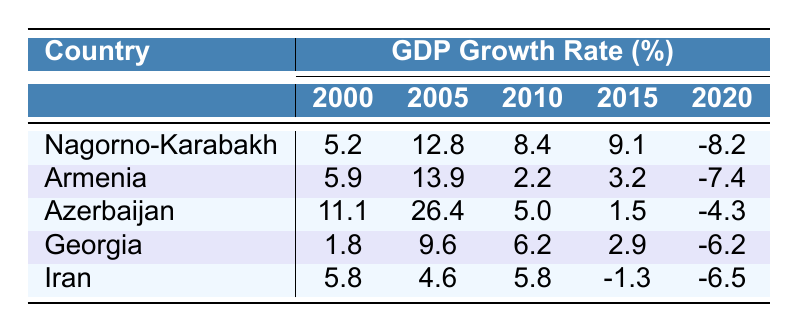What was the GDP growth rate of Nagorno-Karabakh in 2015? According to the table, the value in the row for Nagorno-Karabakh under the year 2015 is 9.1.
Answer: 9.1 Which country had the highest GDP growth rate in 2010? By looking at the table, the highest value in the row for 2010 is 11.1, which corresponds to Azerbaijan.
Answer: Azerbaijan What is the average GDP growth rate of Armenia from 2000 to 2020? To calculate the average, first sum the GDP growth rates for Armenia: (5.9 + 13.9 + 2.2 + 3.2 - 7.4) = 17.8. Then, divide by the number of years, which is 5: 17.8/5 = 3.56.
Answer: 3.56 Did Nagorno-Karabakh experience negative GDP growth in 2020? In the table, Nagorno-Karabakh has a value of -8.2 for the year 2020, which indicates negative growth.
Answer: Yes Which country showed the smallest GDP growth rate in 2005? Looking at the row for 2005, the smallest GDP growth rate is found under Georgia with a value of 9.6.
Answer: Georgia What was the change in GDP growth rate of Azerbaijan from 2015 to 2020? The GDP growth rate for Azerbaijan decreased from 1.5 in 2015 to -4.3 in 2020. To find the change, subtract the two values: 1.5 - (-4.3) = 1.5 + 4.3 = 5.8, indicating a drop.
Answer: 5.8 drop Which nations had positive GDP growth rates in 2000? By checking the values for 2000, both Azerbaijan (11.1) and Armenia (5.9) had positive growth rates while Nagorno-Karabakh (5.2) and Georgia (1.8) also showed positive rates.
Answer: Armenia, Azerbaijan, Nagorno-Karabakh, Georgia What was the trend in GDP growth rates for Nagorno-Karabakh from 2000 to 2020? The values for Nagorno-Karabakh from 2000 to 2015 were positive (5.2, 12.8, 8.4, 9.1), but dropped sharply to -8.2 in 2020, indicating a declining trend followed by negative growth.
Answer: Declining trend with a negative drop in 2020 How does Iran's GDP growth compare to the regional average for 2020? The regional average for 2020 is calculated using all countries' values for that year. The sum of all growth rates in 2020 is (-8.2 - 7.4 - 4.3 - 6.2 - 6.5) = -32.6, and the average is -32.6/5 = -6.52. Iran’s growth rate is -6.5, which is slightly above the average.
Answer: Above average by 0.02 